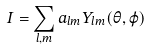<formula> <loc_0><loc_0><loc_500><loc_500>I = \sum _ { l , m } a _ { l m } Y _ { l m } ( \theta , \varphi )</formula> 